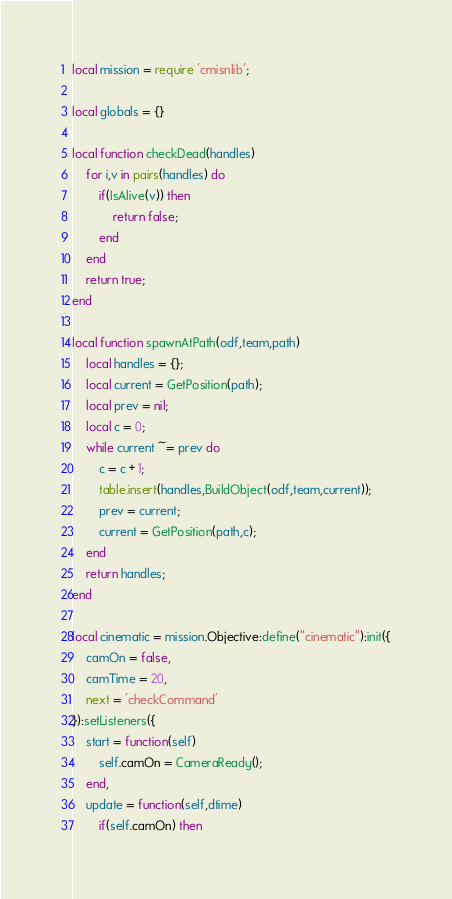Convert code to text. <code><loc_0><loc_0><loc_500><loc_500><_Lua_>local mission = require 'cmisnlib';

local globals = {}

local function checkDead(handles)
    for i,v in pairs(handles) do
        if(IsAlive(v)) then
            return false;
        end
    end
    return true;
end

local function spawnAtPath(odf,team,path)
    local handles = {};
    local current = GetPosition(path);
    local prev = nil;
    local c = 0;
    while current ~= prev do
        c = c + 1;
        table.insert(handles,BuildObject(odf,team,current));
        prev = current;
        current = GetPosition(path,c);
    end
    return handles;
end

local cinematic = mission.Objective:define("cinematic"):init({
    camOn = false,
    camTime = 20,
    next = 'checkCommand'
}):setListeners({
    start = function(self)
        self.camOn = CameraReady();
    end,
    update = function(self,dtime)
        if(self.camOn) then</code> 